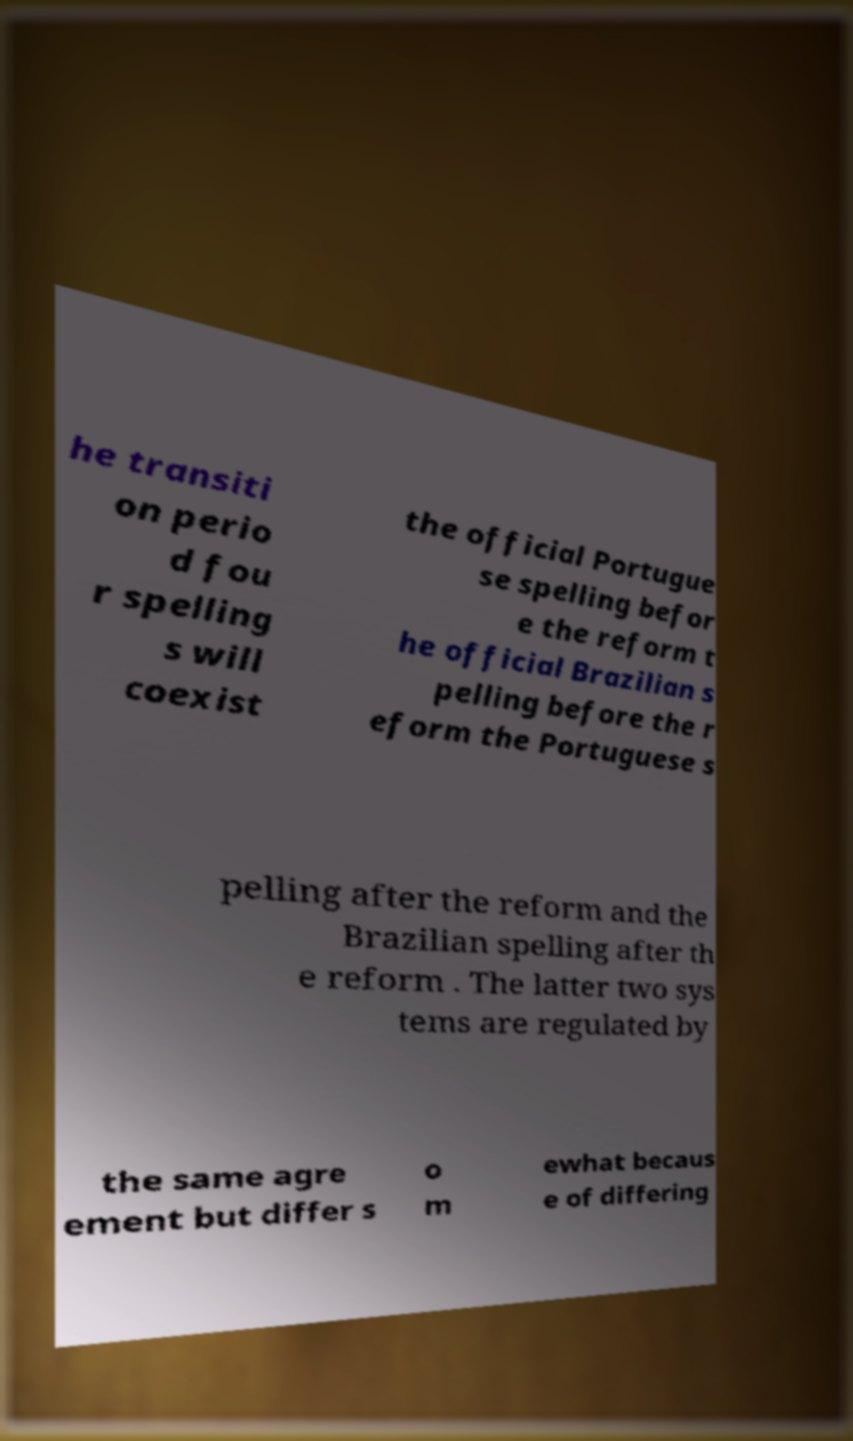Can you accurately transcribe the text from the provided image for me? he transiti on perio d fou r spelling s will coexist the official Portugue se spelling befor e the reform t he official Brazilian s pelling before the r eform the Portuguese s pelling after the reform and the Brazilian spelling after th e reform . The latter two sys tems are regulated by the same agre ement but differ s o m ewhat becaus e of differing 